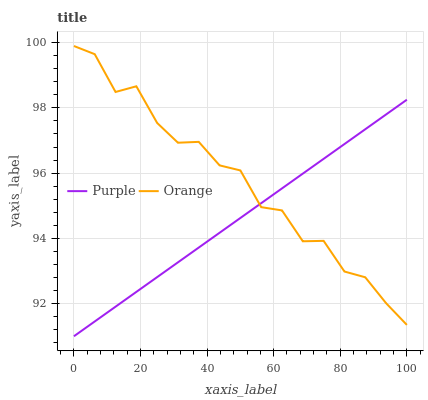Does Purple have the minimum area under the curve?
Answer yes or no. Yes. Does Orange have the maximum area under the curve?
Answer yes or no. Yes. Does Orange have the minimum area under the curve?
Answer yes or no. No. Is Purple the smoothest?
Answer yes or no. Yes. Is Orange the roughest?
Answer yes or no. Yes. Is Orange the smoothest?
Answer yes or no. No. Does Purple have the lowest value?
Answer yes or no. Yes. Does Orange have the lowest value?
Answer yes or no. No. Does Orange have the highest value?
Answer yes or no. Yes. Does Purple intersect Orange?
Answer yes or no. Yes. Is Purple less than Orange?
Answer yes or no. No. Is Purple greater than Orange?
Answer yes or no. No. 